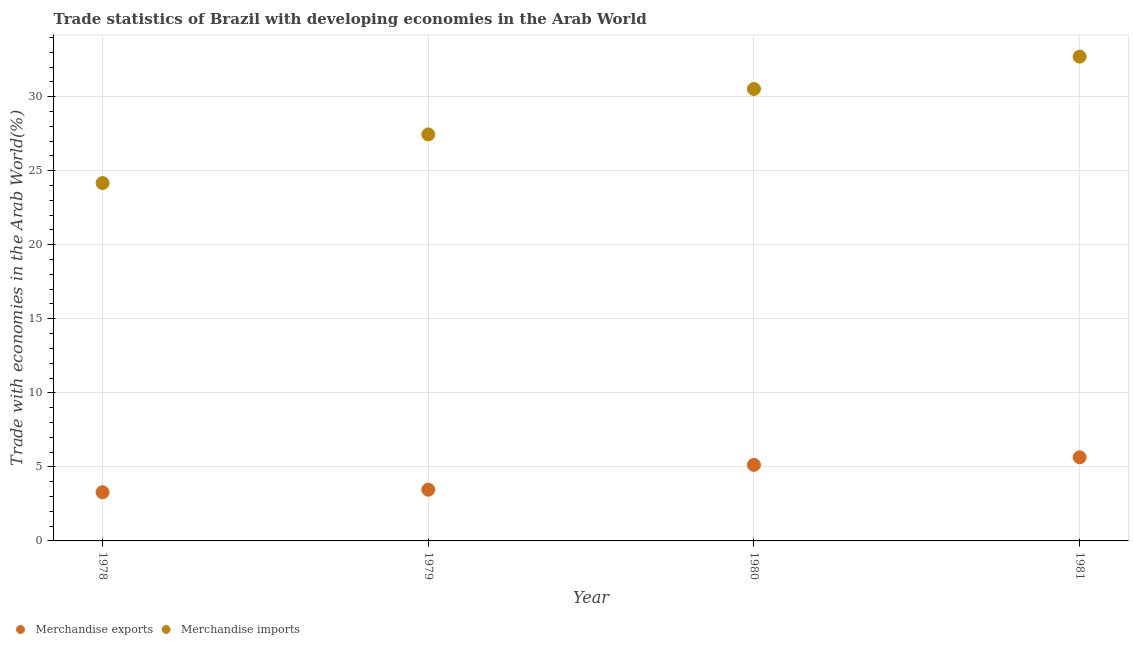What is the merchandise imports in 1980?
Ensure brevity in your answer.  30.52. Across all years, what is the maximum merchandise exports?
Give a very brief answer. 5.65. Across all years, what is the minimum merchandise exports?
Keep it short and to the point. 3.29. In which year was the merchandise exports maximum?
Your response must be concise. 1981. In which year was the merchandise imports minimum?
Your answer should be very brief. 1978. What is the total merchandise exports in the graph?
Ensure brevity in your answer.  17.53. What is the difference between the merchandise exports in 1979 and that in 1980?
Your answer should be very brief. -1.67. What is the difference between the merchandise exports in 1981 and the merchandise imports in 1979?
Provide a succinct answer. -21.81. What is the average merchandise imports per year?
Your answer should be very brief. 28.71. In the year 1979, what is the difference between the merchandise exports and merchandise imports?
Offer a terse response. -23.99. What is the ratio of the merchandise exports in 1978 to that in 1980?
Provide a short and direct response. 0.64. Is the merchandise exports in 1979 less than that in 1980?
Offer a terse response. Yes. What is the difference between the highest and the second highest merchandise imports?
Your answer should be compact. 2.18. What is the difference between the highest and the lowest merchandise exports?
Provide a short and direct response. 2.36. Is the merchandise imports strictly greater than the merchandise exports over the years?
Provide a succinct answer. Yes. Is the merchandise imports strictly less than the merchandise exports over the years?
Keep it short and to the point. No. How many dotlines are there?
Provide a short and direct response. 2. Are the values on the major ticks of Y-axis written in scientific E-notation?
Offer a very short reply. No. Does the graph contain grids?
Offer a very short reply. Yes. Where does the legend appear in the graph?
Your answer should be very brief. Bottom left. How many legend labels are there?
Make the answer very short. 2. What is the title of the graph?
Your answer should be very brief. Trade statistics of Brazil with developing economies in the Arab World. Does "Secondary school" appear as one of the legend labels in the graph?
Your response must be concise. No. What is the label or title of the X-axis?
Give a very brief answer. Year. What is the label or title of the Y-axis?
Give a very brief answer. Trade with economies in the Arab World(%). What is the Trade with economies in the Arab World(%) in Merchandise exports in 1978?
Your answer should be compact. 3.29. What is the Trade with economies in the Arab World(%) of Merchandise imports in 1978?
Provide a short and direct response. 24.17. What is the Trade with economies in the Arab World(%) of Merchandise exports in 1979?
Ensure brevity in your answer.  3.46. What is the Trade with economies in the Arab World(%) in Merchandise imports in 1979?
Make the answer very short. 27.45. What is the Trade with economies in the Arab World(%) of Merchandise exports in 1980?
Offer a very short reply. 5.13. What is the Trade with economies in the Arab World(%) of Merchandise imports in 1980?
Offer a terse response. 30.52. What is the Trade with economies in the Arab World(%) in Merchandise exports in 1981?
Your answer should be very brief. 5.65. What is the Trade with economies in the Arab World(%) in Merchandise imports in 1981?
Keep it short and to the point. 32.7. Across all years, what is the maximum Trade with economies in the Arab World(%) in Merchandise exports?
Ensure brevity in your answer.  5.65. Across all years, what is the maximum Trade with economies in the Arab World(%) of Merchandise imports?
Make the answer very short. 32.7. Across all years, what is the minimum Trade with economies in the Arab World(%) in Merchandise exports?
Your answer should be very brief. 3.29. Across all years, what is the minimum Trade with economies in the Arab World(%) of Merchandise imports?
Offer a very short reply. 24.17. What is the total Trade with economies in the Arab World(%) in Merchandise exports in the graph?
Your answer should be very brief. 17.53. What is the total Trade with economies in the Arab World(%) in Merchandise imports in the graph?
Give a very brief answer. 114.85. What is the difference between the Trade with economies in the Arab World(%) of Merchandise exports in 1978 and that in 1979?
Make the answer very short. -0.17. What is the difference between the Trade with economies in the Arab World(%) of Merchandise imports in 1978 and that in 1979?
Your response must be concise. -3.28. What is the difference between the Trade with economies in the Arab World(%) of Merchandise exports in 1978 and that in 1980?
Give a very brief answer. -1.85. What is the difference between the Trade with economies in the Arab World(%) of Merchandise imports in 1978 and that in 1980?
Your answer should be compact. -6.35. What is the difference between the Trade with economies in the Arab World(%) of Merchandise exports in 1978 and that in 1981?
Offer a terse response. -2.36. What is the difference between the Trade with economies in the Arab World(%) in Merchandise imports in 1978 and that in 1981?
Your answer should be compact. -8.54. What is the difference between the Trade with economies in the Arab World(%) of Merchandise exports in 1979 and that in 1980?
Offer a terse response. -1.67. What is the difference between the Trade with economies in the Arab World(%) of Merchandise imports in 1979 and that in 1980?
Keep it short and to the point. -3.07. What is the difference between the Trade with economies in the Arab World(%) in Merchandise exports in 1979 and that in 1981?
Make the answer very short. -2.19. What is the difference between the Trade with economies in the Arab World(%) of Merchandise imports in 1979 and that in 1981?
Your answer should be very brief. -5.25. What is the difference between the Trade with economies in the Arab World(%) of Merchandise exports in 1980 and that in 1981?
Make the answer very short. -0.51. What is the difference between the Trade with economies in the Arab World(%) of Merchandise imports in 1980 and that in 1981?
Keep it short and to the point. -2.18. What is the difference between the Trade with economies in the Arab World(%) of Merchandise exports in 1978 and the Trade with economies in the Arab World(%) of Merchandise imports in 1979?
Your answer should be compact. -24.17. What is the difference between the Trade with economies in the Arab World(%) of Merchandise exports in 1978 and the Trade with economies in the Arab World(%) of Merchandise imports in 1980?
Provide a succinct answer. -27.24. What is the difference between the Trade with economies in the Arab World(%) of Merchandise exports in 1978 and the Trade with economies in the Arab World(%) of Merchandise imports in 1981?
Offer a very short reply. -29.42. What is the difference between the Trade with economies in the Arab World(%) of Merchandise exports in 1979 and the Trade with economies in the Arab World(%) of Merchandise imports in 1980?
Your answer should be compact. -27.06. What is the difference between the Trade with economies in the Arab World(%) of Merchandise exports in 1979 and the Trade with economies in the Arab World(%) of Merchandise imports in 1981?
Ensure brevity in your answer.  -29.24. What is the difference between the Trade with economies in the Arab World(%) in Merchandise exports in 1980 and the Trade with economies in the Arab World(%) in Merchandise imports in 1981?
Provide a short and direct response. -27.57. What is the average Trade with economies in the Arab World(%) of Merchandise exports per year?
Provide a succinct answer. 4.38. What is the average Trade with economies in the Arab World(%) in Merchandise imports per year?
Your answer should be very brief. 28.71. In the year 1978, what is the difference between the Trade with economies in the Arab World(%) of Merchandise exports and Trade with economies in the Arab World(%) of Merchandise imports?
Give a very brief answer. -20.88. In the year 1979, what is the difference between the Trade with economies in the Arab World(%) in Merchandise exports and Trade with economies in the Arab World(%) in Merchandise imports?
Make the answer very short. -23.99. In the year 1980, what is the difference between the Trade with economies in the Arab World(%) in Merchandise exports and Trade with economies in the Arab World(%) in Merchandise imports?
Ensure brevity in your answer.  -25.39. In the year 1981, what is the difference between the Trade with economies in the Arab World(%) of Merchandise exports and Trade with economies in the Arab World(%) of Merchandise imports?
Provide a succinct answer. -27.06. What is the ratio of the Trade with economies in the Arab World(%) of Merchandise exports in 1978 to that in 1979?
Make the answer very short. 0.95. What is the ratio of the Trade with economies in the Arab World(%) of Merchandise imports in 1978 to that in 1979?
Your response must be concise. 0.88. What is the ratio of the Trade with economies in the Arab World(%) of Merchandise exports in 1978 to that in 1980?
Keep it short and to the point. 0.64. What is the ratio of the Trade with economies in the Arab World(%) of Merchandise imports in 1978 to that in 1980?
Make the answer very short. 0.79. What is the ratio of the Trade with economies in the Arab World(%) in Merchandise exports in 1978 to that in 1981?
Offer a terse response. 0.58. What is the ratio of the Trade with economies in the Arab World(%) in Merchandise imports in 1978 to that in 1981?
Provide a succinct answer. 0.74. What is the ratio of the Trade with economies in the Arab World(%) of Merchandise exports in 1979 to that in 1980?
Give a very brief answer. 0.67. What is the ratio of the Trade with economies in the Arab World(%) of Merchandise imports in 1979 to that in 1980?
Provide a short and direct response. 0.9. What is the ratio of the Trade with economies in the Arab World(%) in Merchandise exports in 1979 to that in 1981?
Provide a succinct answer. 0.61. What is the ratio of the Trade with economies in the Arab World(%) in Merchandise imports in 1979 to that in 1981?
Offer a terse response. 0.84. What is the ratio of the Trade with economies in the Arab World(%) in Merchandise exports in 1980 to that in 1981?
Your answer should be compact. 0.91. What is the difference between the highest and the second highest Trade with economies in the Arab World(%) of Merchandise exports?
Your answer should be compact. 0.51. What is the difference between the highest and the second highest Trade with economies in the Arab World(%) of Merchandise imports?
Offer a terse response. 2.18. What is the difference between the highest and the lowest Trade with economies in the Arab World(%) of Merchandise exports?
Offer a terse response. 2.36. What is the difference between the highest and the lowest Trade with economies in the Arab World(%) of Merchandise imports?
Offer a terse response. 8.54. 